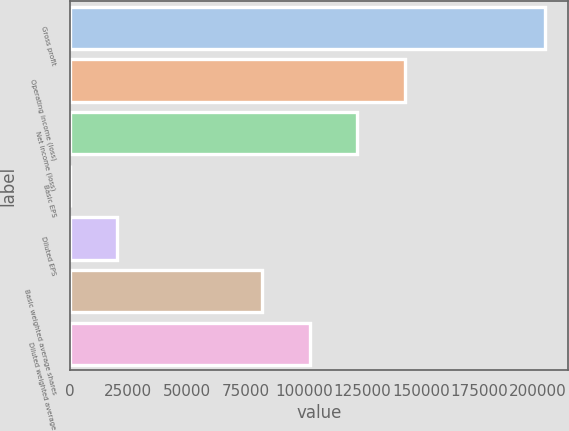Convert chart. <chart><loc_0><loc_0><loc_500><loc_500><bar_chart><fcel>Gross profit<fcel>Operating income (loss)<fcel>Net income (loss)<fcel>Basic EPS<fcel>Diluted EPS<fcel>Basic weighted average shares<fcel>Diluted weighted average<nl><fcel>202858<fcel>143153<fcel>122867<fcel>1.45<fcel>20287.1<fcel>82296<fcel>102582<nl></chart> 